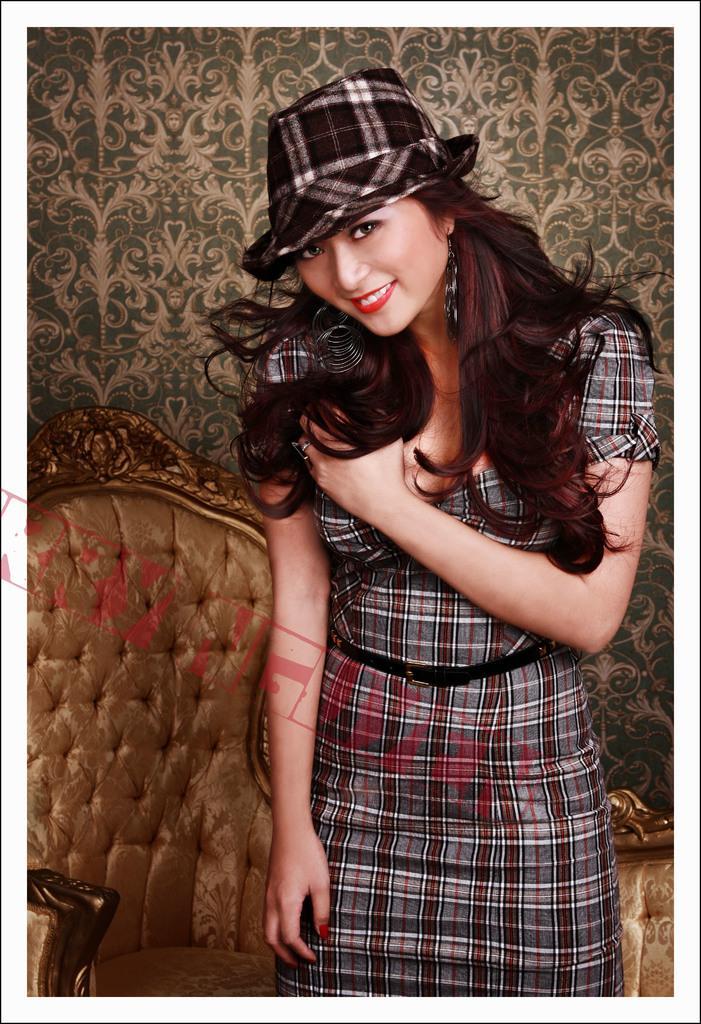In one or two sentences, can you explain what this image depicts? In this image we can see a girl who is wearing a cap and behind there is a sofa. 